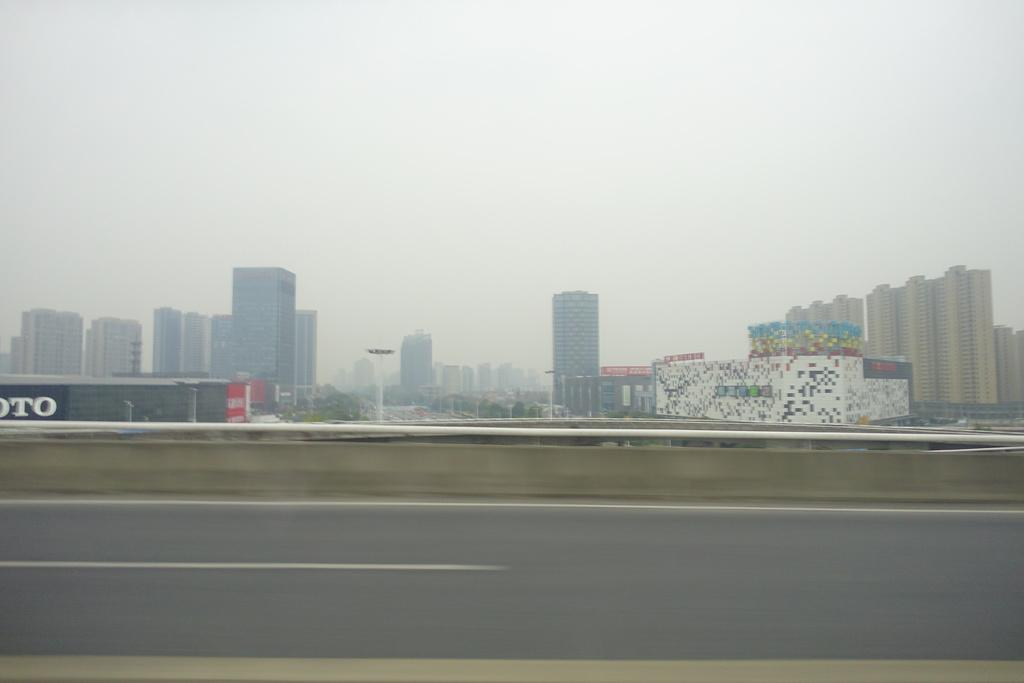What is the main feature of the image? There is a road in the image. What else can be seen in the middle of the image? There are buildings in the middle of the image. What is visible in the background of the image? The sky is visible in the background of the image. What type of vegetable is growing on the side of the road in the image? There are no vegetables visible in the image; it only features a road, buildings, and the sky. 